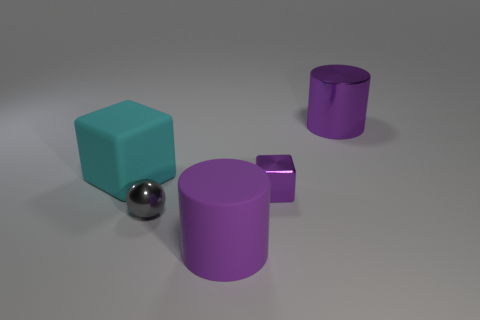There is a cylinder that is in front of the big thing that is to the right of the purple rubber cylinder; what is its color?
Offer a very short reply. Purple. What number of gray things are big shiny cylinders or tiny things?
Give a very brief answer. 1. There is a metallic thing that is both in front of the large metal cylinder and right of the gray ball; what is its color?
Your response must be concise. Purple. How many large things are gray objects or purple cylinders?
Your answer should be very brief. 2. There is a purple matte thing that is the same shape as the large purple shiny object; what size is it?
Keep it short and to the point. Large. What is the shape of the purple rubber object?
Your answer should be very brief. Cylinder. Is the tiny gray thing made of the same material as the large cylinder that is in front of the matte cube?
Provide a short and direct response. No. How many rubber objects are gray things or cylinders?
Give a very brief answer. 1. There is a cylinder in front of the gray ball; what size is it?
Your response must be concise. Large. There is a purple cube that is the same material as the tiny gray thing; what size is it?
Give a very brief answer. Small. 